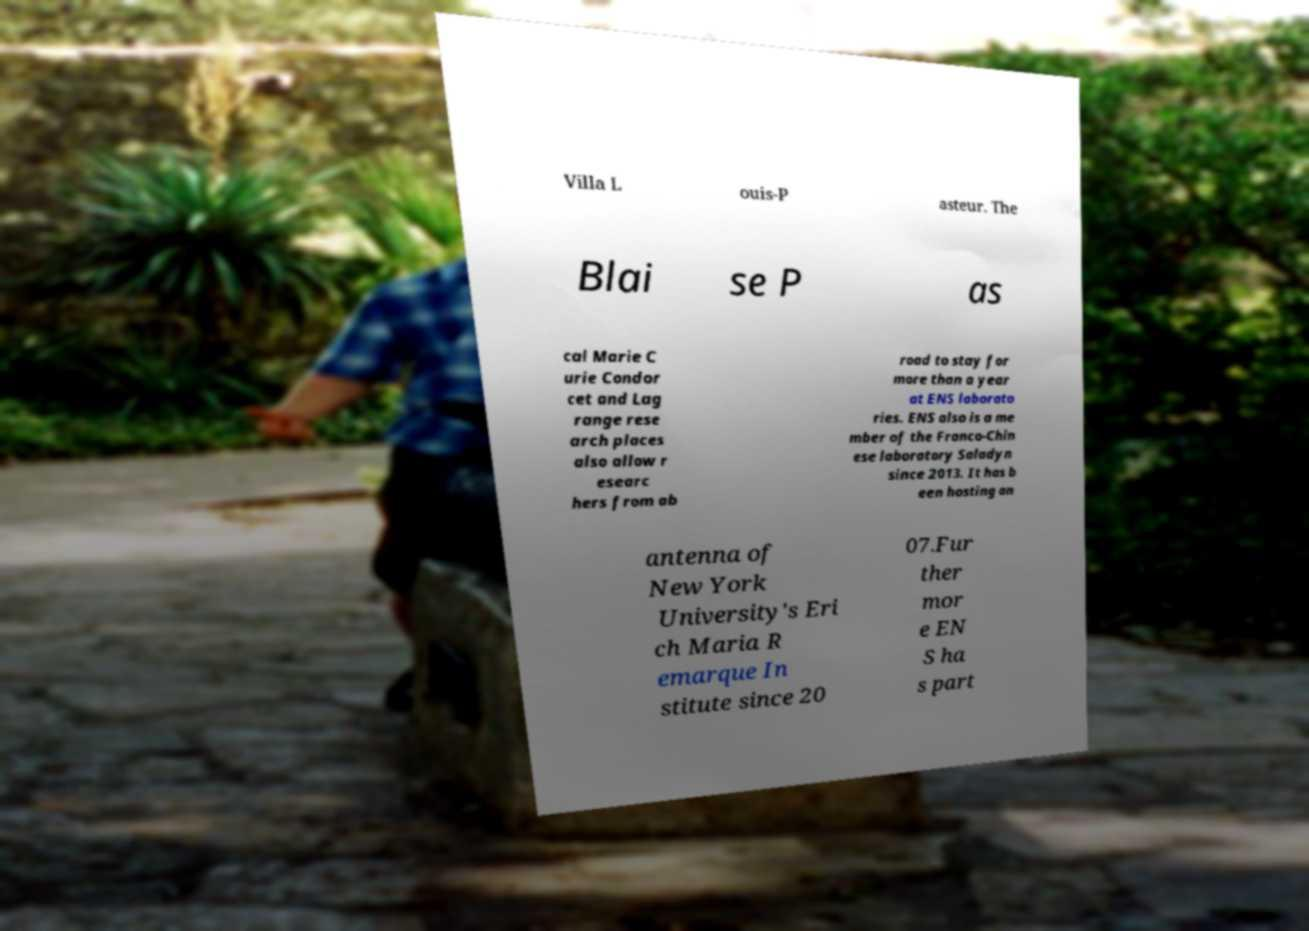What messages or text are displayed in this image? I need them in a readable, typed format. Villa L ouis-P asteur. The Blai se P as cal Marie C urie Condor cet and Lag range rese arch places also allow r esearc hers from ab road to stay for more than a year at ENS laborato ries. ENS also is a me mber of the Franco-Chin ese laboratory Saladyn since 2013. It has b een hosting an antenna of New York University's Eri ch Maria R emarque In stitute since 20 07.Fur ther mor e EN S ha s part 